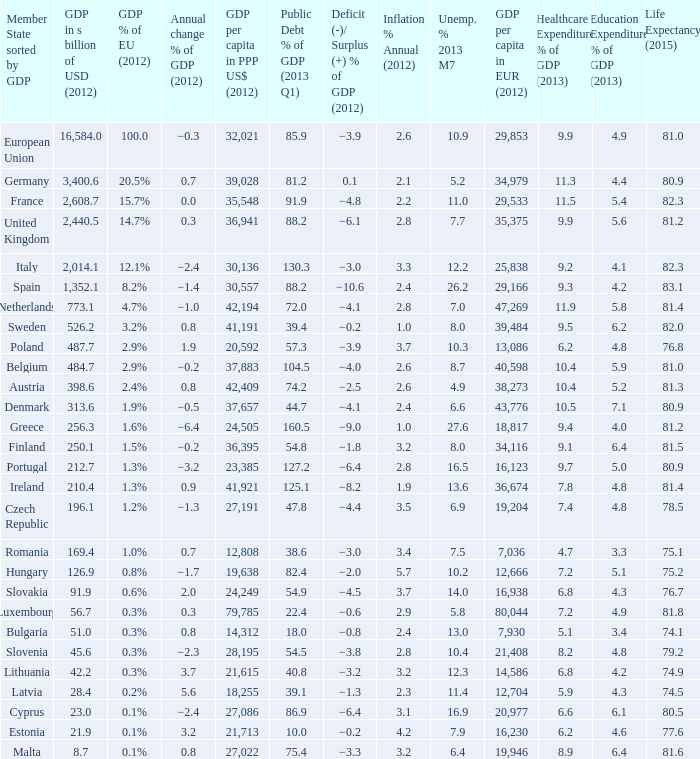What is the GDP % of EU in 2012 of the country with a GDP in billions of USD in 2012 of 256.3? 1.6%. 